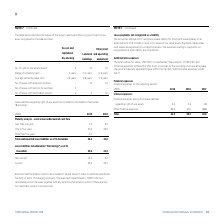According to Torm's financial document, Why are extension and termination options are included in several leases? to optimize operational flexibility in terms of managing contracts. The document states: "n options are included in several leases in order to optimize operational flexibility in terms of managing contracts. The lease term determined by TOR..." Also, What is the lease term determined by TORM? Based on the financial document, the answer is the noncancellable period of a lease, together with any extension/termination options if these are/are not reasonably certain to be exercised. Also, What are the different maturity terms under maturity analysis - contractual undiscounted cash flow? The document contains multiple relevant values: Less than one year, One to five years, More than five years. From the document: "More than five years 0.1 - One to five years 27.6 25.6 Less than one year 7.5 5.2..." Additionally, In which year was the amount of Current lease liabilities larger? According to the financial document, 2018. The relevant text states: "USDm 2019 2018..." Also, can you calculate: What was the change in non-current lease liabilities? Based on the calculation: 10.2-3.2, the result is 7 (in millions). This is based on the information: "Non-current 10.2 3.2 Non-current 10.2 3.2..." The key data points involved are: 10.2, 3.2. Also, can you calculate: What was the percentage change in non-current lease liabilities? To answer this question, I need to perform calculations using the financial data. The calculation is: (10.2-3.2)/3.2, which equals 218.75 (percentage). This is based on the information: "Non-current 10.2 3.2 Non-current 10.2 3.2..." The key data points involved are: 10.2, 3.2. 